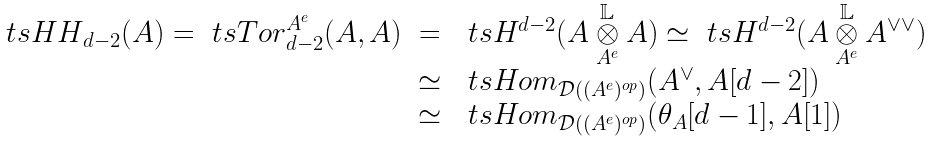Convert formula to latex. <formula><loc_0><loc_0><loc_500><loc_500>\begin{array} { r c l } \ t s { H H } _ { d - 2 } ( A ) = \ t s { T o r } _ { d - 2 } ^ { A ^ { e } } ( A , A ) & = & \ t s H ^ { d - 2 } ( A \overset { \mathbb { L } } { \underset { A ^ { e } } { \otimes } } A ) \simeq \ t s H ^ { d - 2 } ( A \overset { \mathbb { L } } { \underset { A ^ { e } } { \otimes } } A ^ { \vee \vee } ) \\ & \simeq & \ t s { H o m } _ { \mathcal { D } ( ( A ^ { e } ) ^ { o p } ) } ( A ^ { \vee } , A [ d - 2 ] ) \\ & \simeq & \ t s { H o m } _ { \mathcal { D } ( ( A ^ { e } ) ^ { o p } ) } ( \theta _ { A } [ d - 1 ] , A [ 1 ] ) \end{array}</formula> 